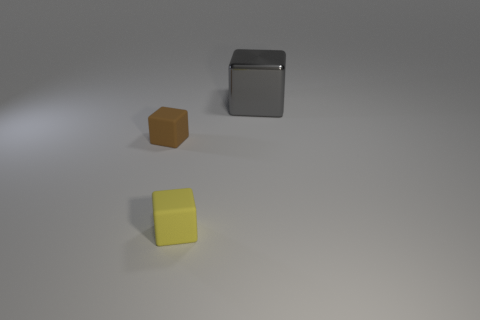Are there any small brown blocks in front of the matte object that is behind the rubber object that is in front of the small brown matte thing?
Make the answer very short. No. What is the color of the other matte object that is the same shape as the tiny brown matte thing?
Provide a short and direct response. Yellow. How many yellow things are big objects or small rubber blocks?
Keep it short and to the point. 1. There is a object left of the small matte block right of the brown matte cube; what is it made of?
Your answer should be compact. Rubber. Is the shape of the large gray metallic object the same as the yellow object?
Provide a succinct answer. Yes. The cube that is the same size as the brown object is what color?
Offer a very short reply. Yellow. Is there a large metallic cylinder of the same color as the metallic cube?
Provide a succinct answer. No. Are any blue spheres visible?
Ensure brevity in your answer.  No. Does the small thing that is in front of the brown rubber cube have the same material as the tiny brown block?
Provide a succinct answer. Yes. What number of gray things have the same size as the yellow matte thing?
Give a very brief answer. 0. 